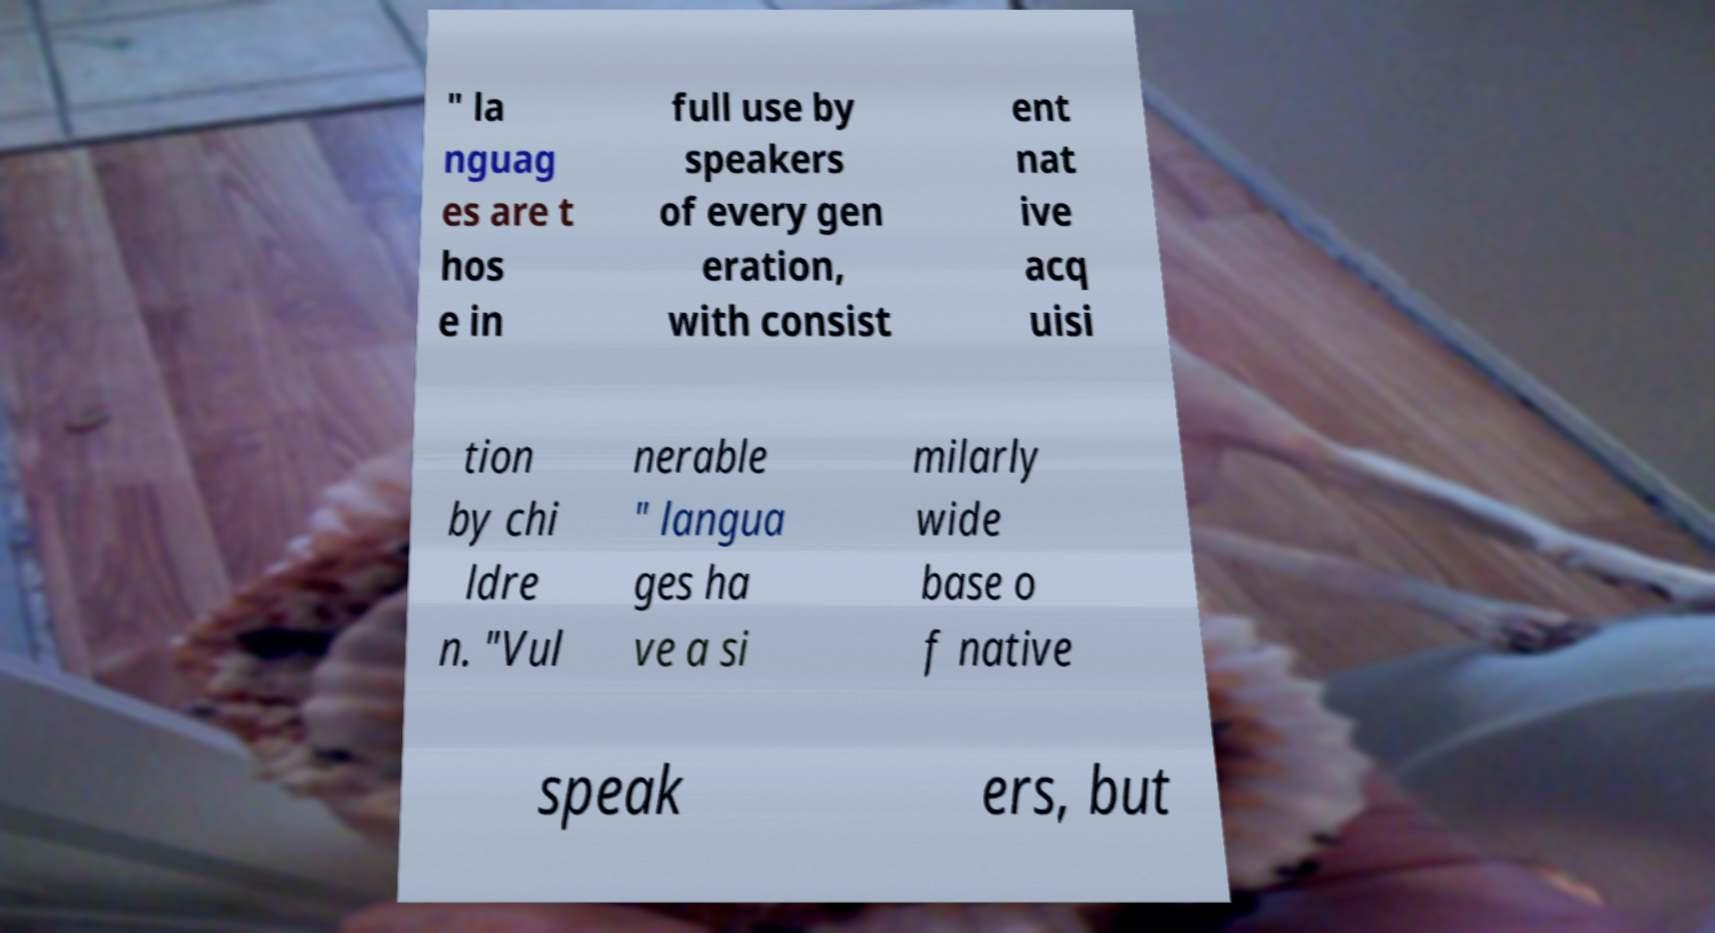There's text embedded in this image that I need extracted. Can you transcribe it verbatim? " la nguag es are t hos e in full use by speakers of every gen eration, with consist ent nat ive acq uisi tion by chi ldre n. "Vul nerable " langua ges ha ve a si milarly wide base o f native speak ers, but 